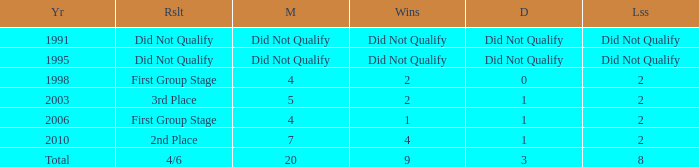What was the result for the team with 3 draws? 4/6. 